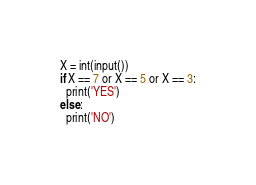Convert code to text. <code><loc_0><loc_0><loc_500><loc_500><_Python_>X = int(input())
if X == 7 or X == 5 or X == 3:
  print('YES')
else:
  print('NO')</code> 